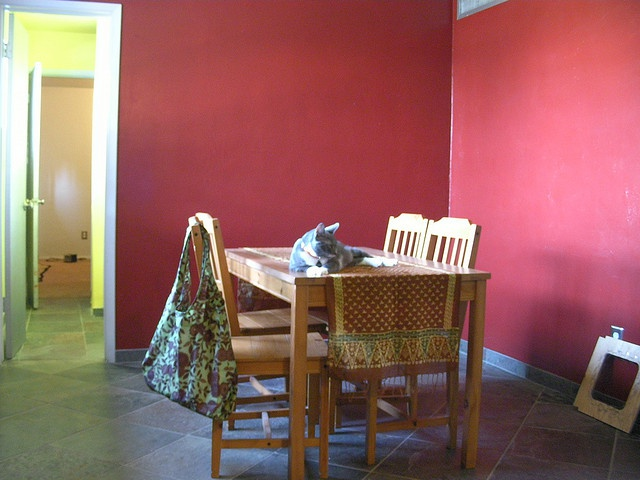Describe the objects in this image and their specific colors. I can see dining table in darkgray, maroon, and lightgray tones, chair in darkgray, maroon, and gray tones, handbag in darkgray, gray, maroon, black, and darkgreen tones, cat in darkgray, gray, white, and lightblue tones, and chair in darkgray, white, brown, and maroon tones in this image. 